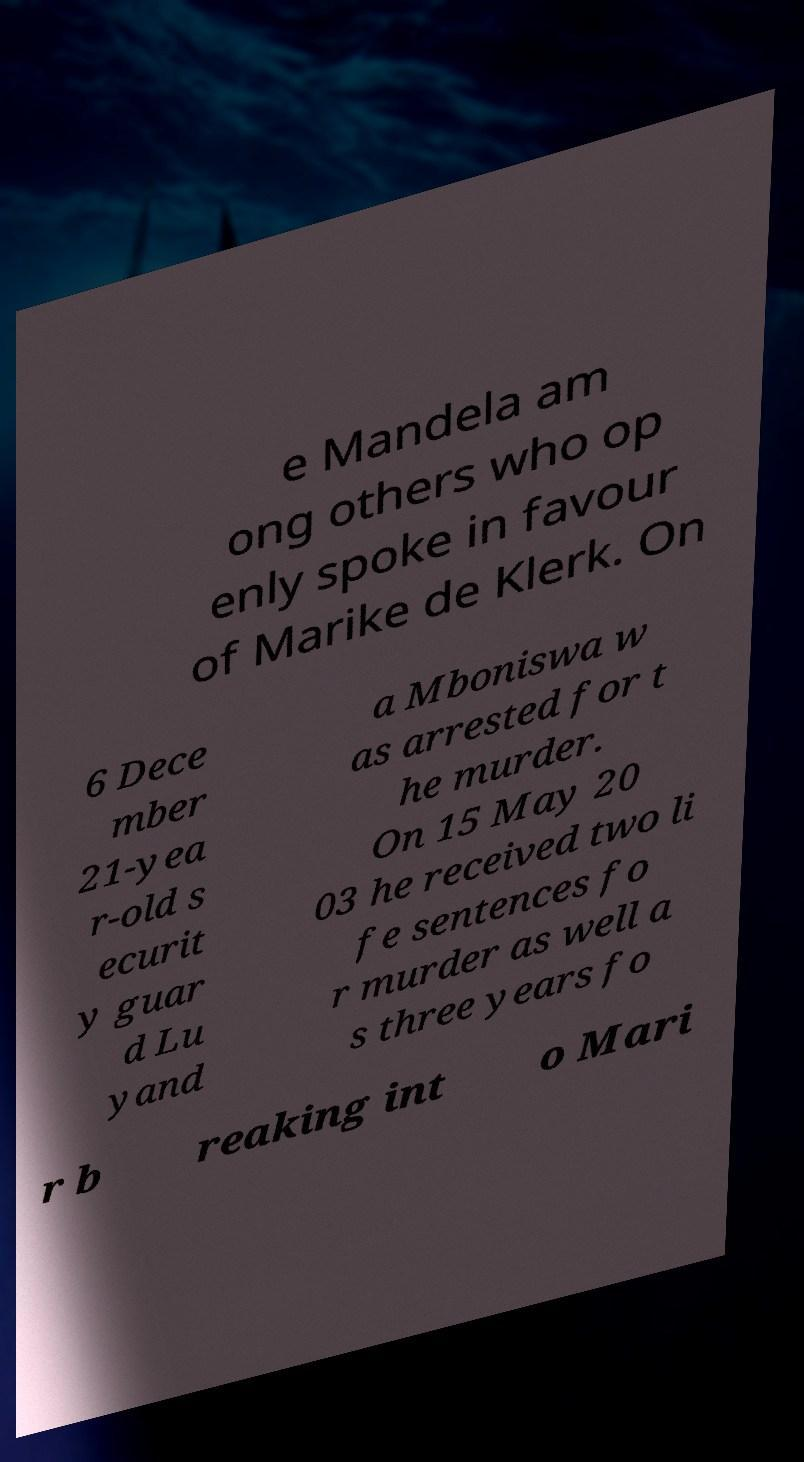Can you read and provide the text displayed in the image?This photo seems to have some interesting text. Can you extract and type it out for me? e Mandela am ong others who op enly spoke in favour of Marike de Klerk. On 6 Dece mber 21-yea r-old s ecurit y guar d Lu yand a Mboniswa w as arrested for t he murder. On 15 May 20 03 he received two li fe sentences fo r murder as well a s three years fo r b reaking int o Mari 